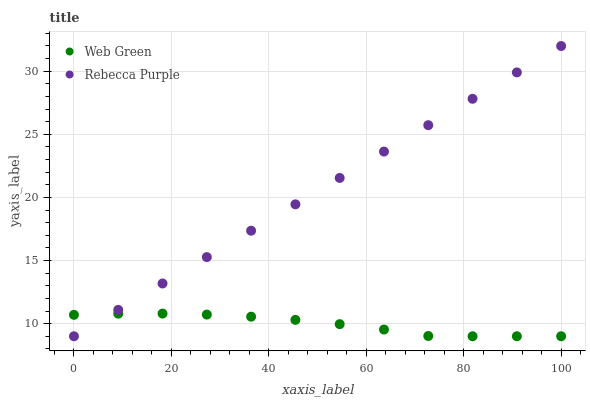Does Web Green have the minimum area under the curve?
Answer yes or no. Yes. Does Rebecca Purple have the maximum area under the curve?
Answer yes or no. Yes. Does Web Green have the maximum area under the curve?
Answer yes or no. No. Is Rebecca Purple the smoothest?
Answer yes or no. Yes. Is Web Green the roughest?
Answer yes or no. Yes. Is Web Green the smoothest?
Answer yes or no. No. Does Rebecca Purple have the lowest value?
Answer yes or no. Yes. Does Rebecca Purple have the highest value?
Answer yes or no. Yes. Does Web Green have the highest value?
Answer yes or no. No. Does Rebecca Purple intersect Web Green?
Answer yes or no. Yes. Is Rebecca Purple less than Web Green?
Answer yes or no. No. Is Rebecca Purple greater than Web Green?
Answer yes or no. No. 